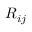<formula> <loc_0><loc_0><loc_500><loc_500>R _ { i j }</formula> 